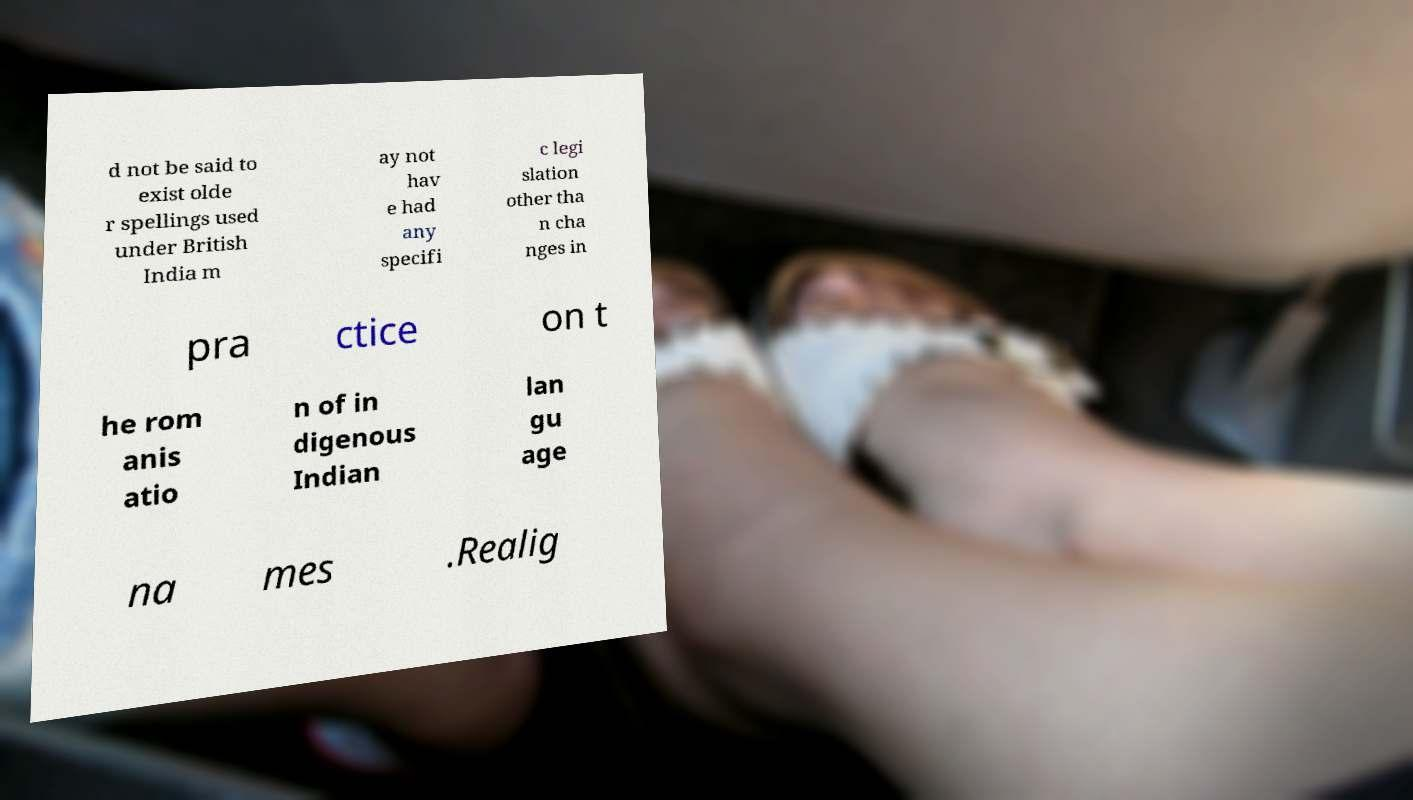What messages or text are displayed in this image? I need them in a readable, typed format. d not be said to exist olde r spellings used under British India m ay not hav e had any specifi c legi slation other tha n cha nges in pra ctice on t he rom anis atio n of in digenous Indian lan gu age na mes .Realig 